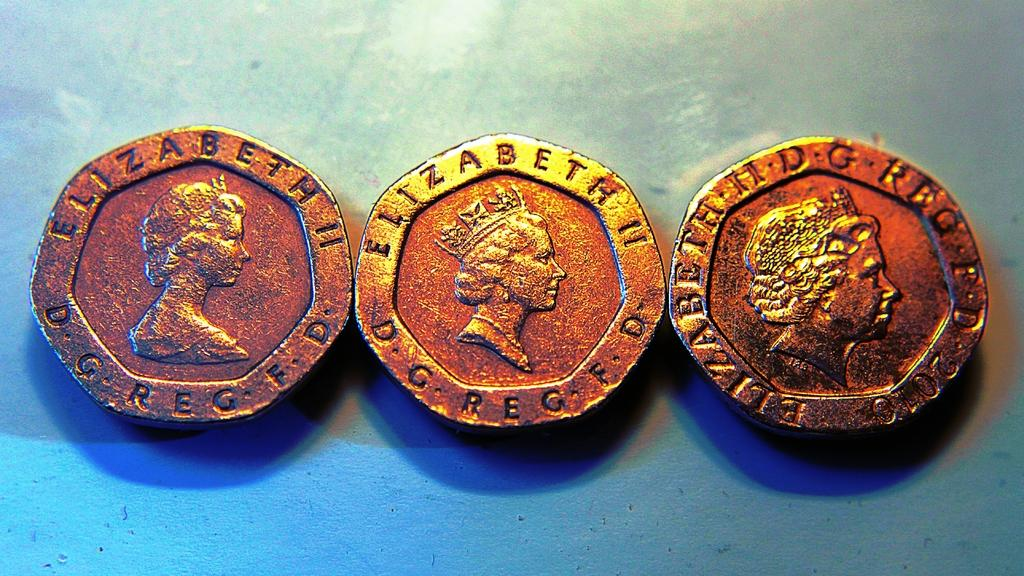<image>
Give a short and clear explanation of the subsequent image. Three gold coins with Elizabeth II on them are on a teal background. 